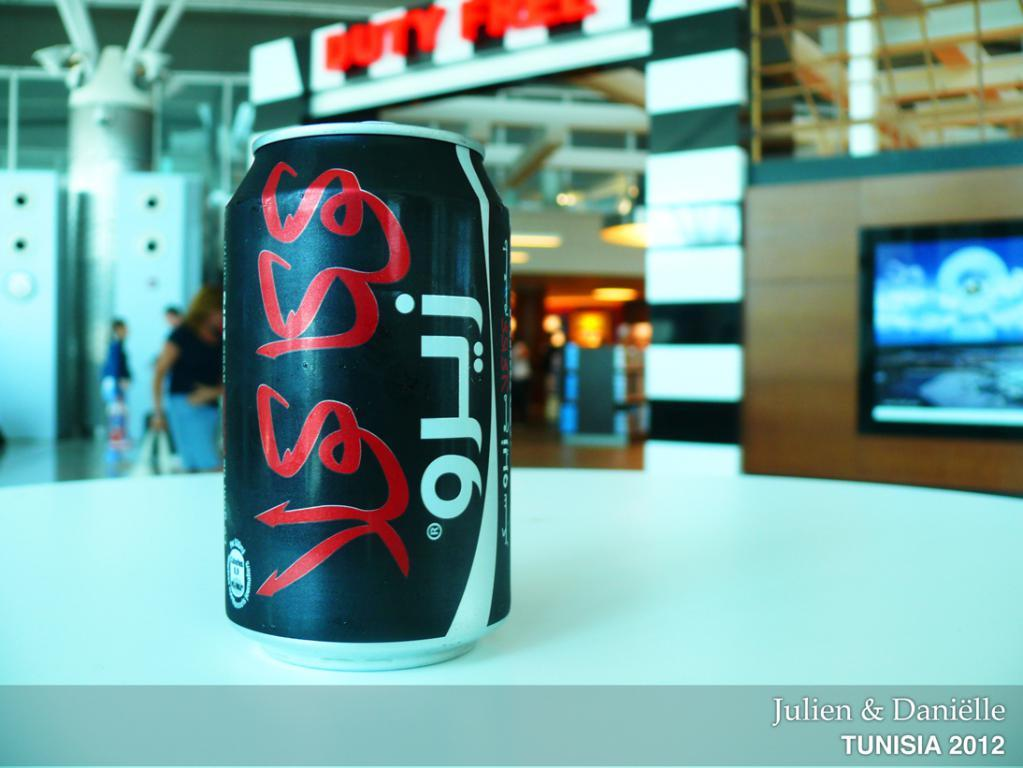<image>
Relay a brief, clear account of the picture shown. A photo by Julien & Danielle shows a black can with white and red Arabic writing on a white counter-top. 